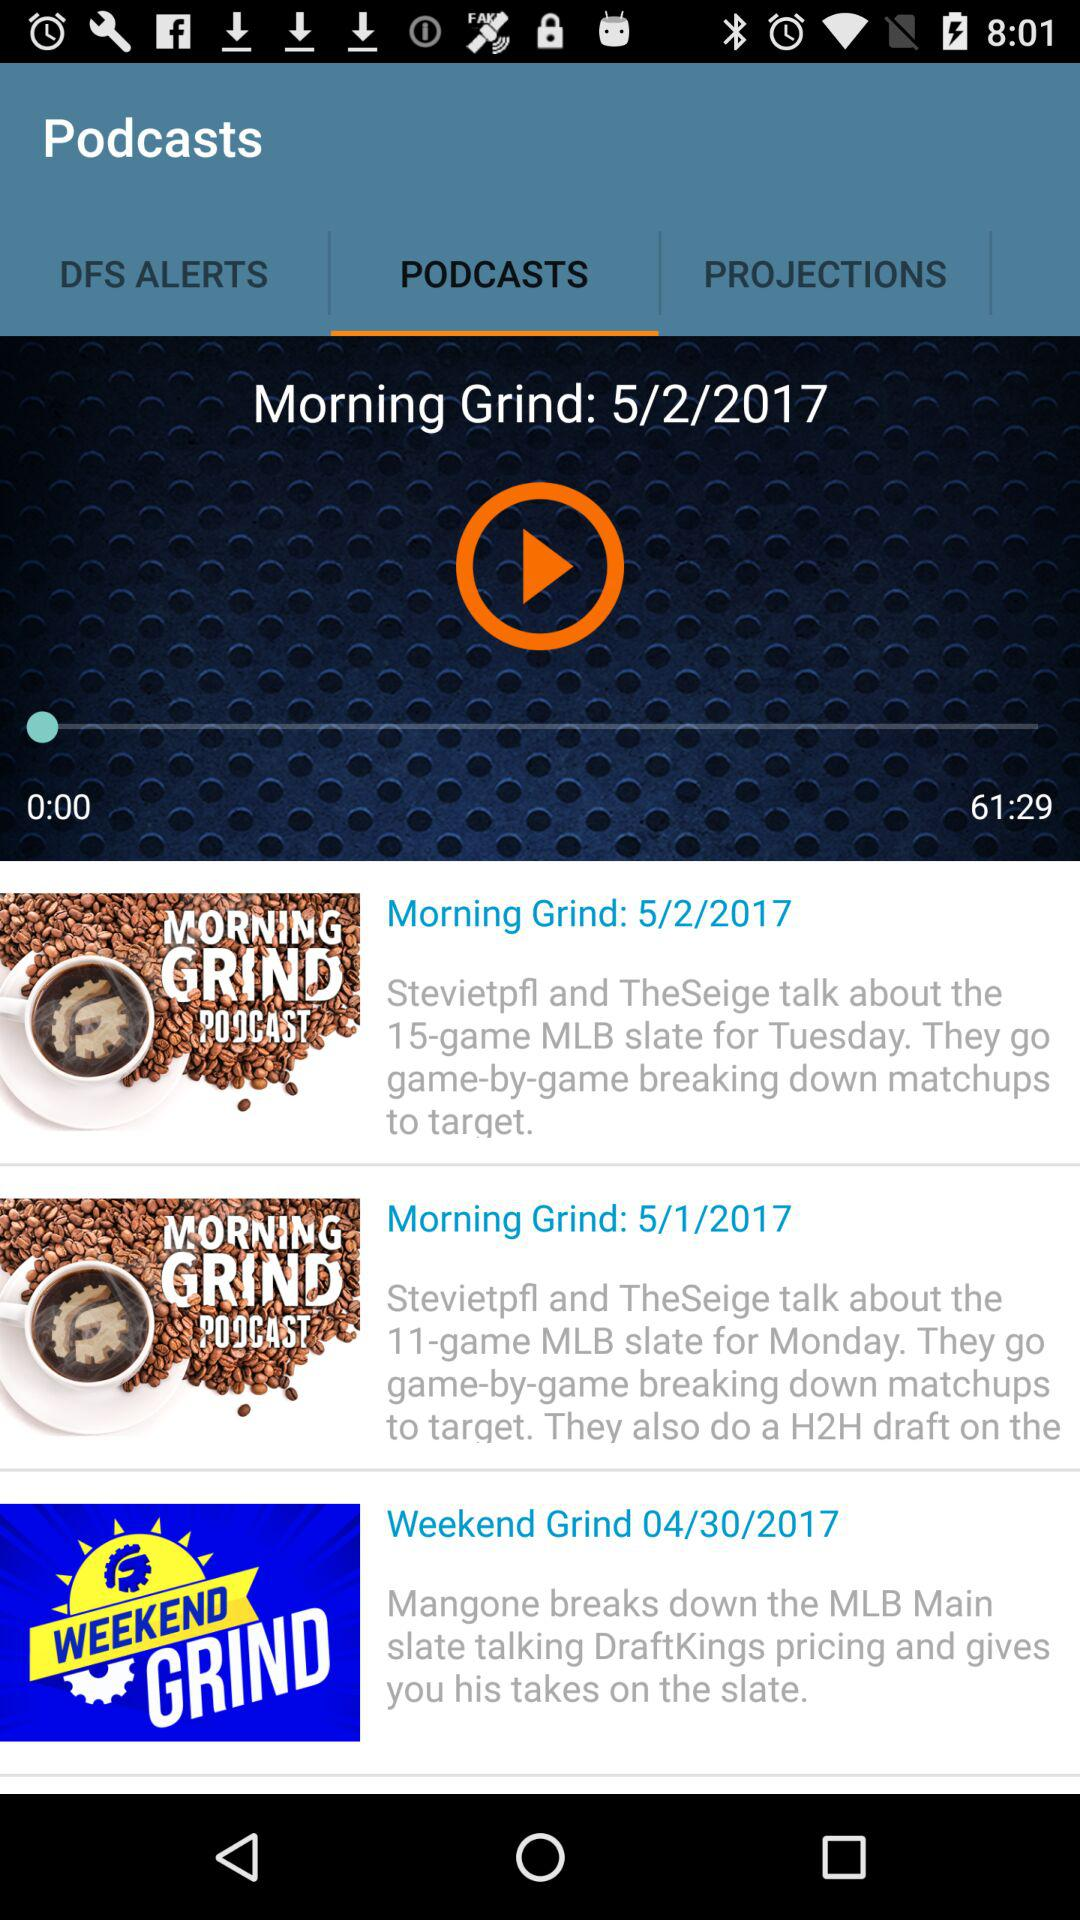Which tab is selected? The selected tab is "PODCASTS". 